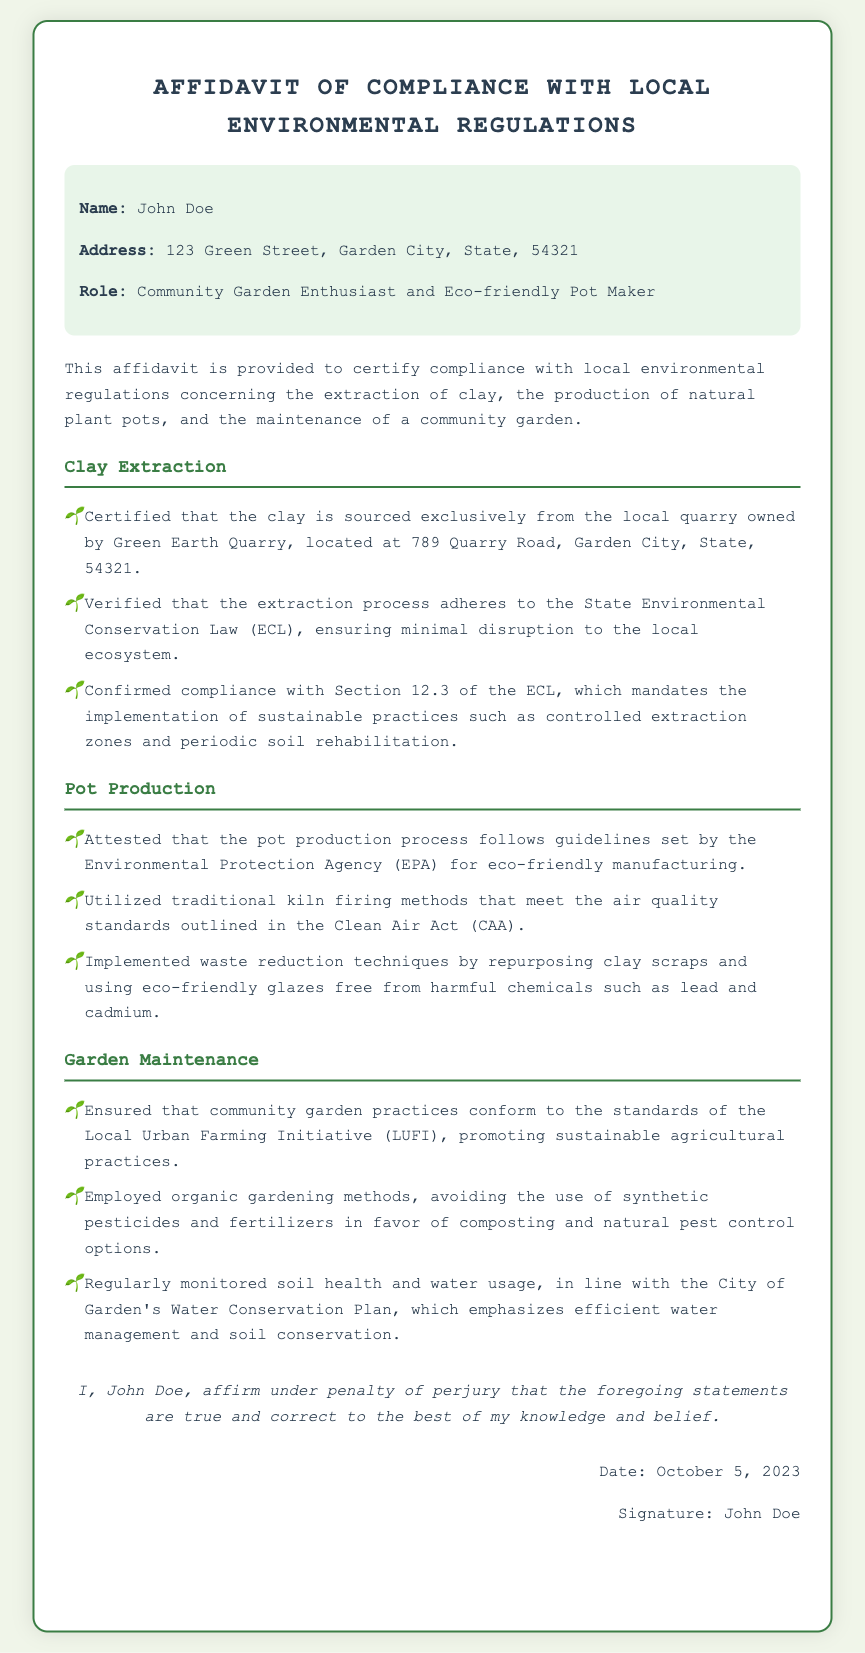What is the name of the affiant? The name of the affiant is mentioned at the beginning of the document.
Answer: John Doe What is the address of the affiant? The affidavit provides the full address details of the affiant, which is stated clearly.
Answer: 123 Green Street, Garden City, State, 54321 What is the date of the affidavit? The date is explicitly mentioned in the signature section of the document.
Answer: October 5, 2023 Which quarry does the affiant source clay from? The document specifies the name of the quarry from which the clay is sourced.
Answer: Green Earth Quarry What environmental legislation is mentioned regarding clay extraction? The affidavit references a specific law related to environmental compliance for clay extraction.
Answer: State Environmental Conservation Law (ECL) What production methods does the affiant use for eco-friendly pots? The document explains the production methods employed by the affiant for making pots.
Answer: Traditional kiln firing methods What gardening methods are employed in the community garden? The document outlines the gardening practices followed by the affiant in the community garden.
Answer: Organic gardening methods What organization sets the standards for local gardening practices? The document mentions an initiative related to local urban farming that sets these standards.
Answer: Local Urban Farming Initiative (LUFI) What type of glazes does the affiant use? The affidavit describes the type of glazes used in the pot production process.
Answer: Eco-friendly glazes free from harmful chemicals 